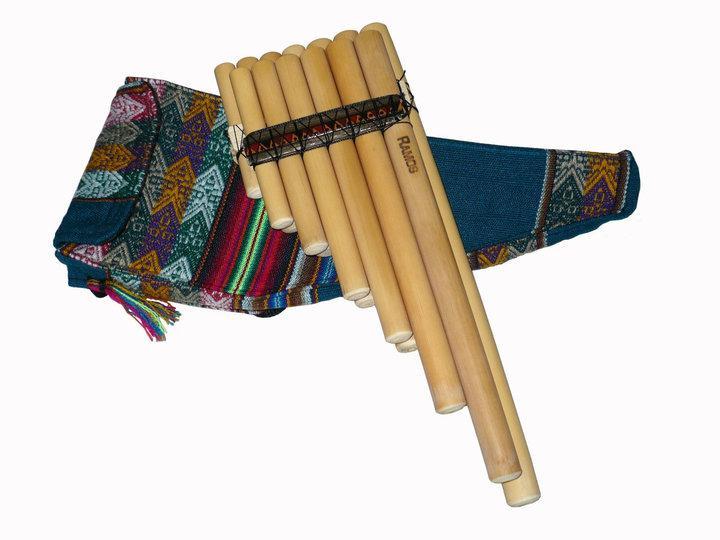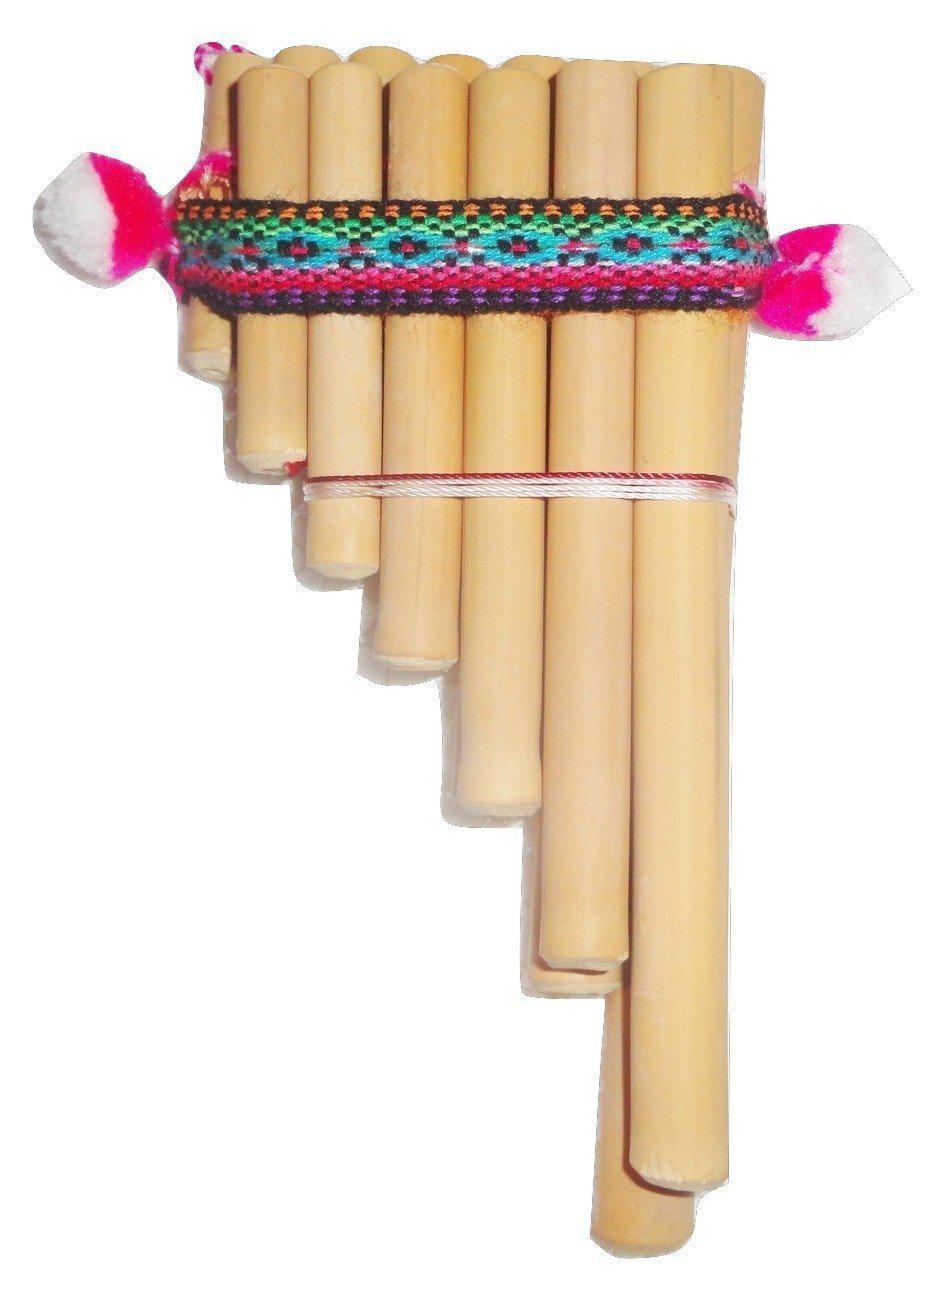The first image is the image on the left, the second image is the image on the right. Examine the images to the left and right. Is the description "A carrying bag sits under the instrument in the image on the left." accurate? Answer yes or no. Yes. The first image is the image on the left, the second image is the image on the right. For the images displayed, is the sentence "The right image features an instrument with pom-pom balls on each side displayed vertically, with its wooden tube shapes arranged left-to-right from shortest to longest." factually correct? Answer yes or no. Yes. 